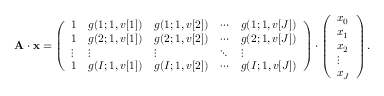<formula> <loc_0><loc_0><loc_500><loc_500>A \cdot x = \left ( \begin{array} { l l l l l } { 1 } & { g ( 1 ; 1 , v [ 1 ] ) } & { g ( 1 ; 1 , v [ 2 ] ) } & { \cdots } & { g ( 1 ; 1 , v [ J ] ) } \\ { 1 } & { g ( 2 ; 1 , v [ 1 ] ) } & { g ( 2 ; 1 , v [ 2 ] ) } & { \cdots } & { g ( 2 ; 1 , v [ J ] ) } \\ { \vdots } & { \vdots } & { \vdots } & { \ddots } & { \vdots } \\ { 1 } & { g ( I ; 1 , v [ 1 ] ) } & { g ( I ; 1 , v [ 2 ] ) } & { \cdots } & { g ( I ; 1 , v [ J ] ) } \end{array} \right ) \cdot \left ( \begin{array} { l } { x _ { 0 } } \\ { x _ { 1 } } \\ { x _ { 2 } } \\ { \vdots } \\ { x _ { J } } \end{array} \right ) .</formula> 